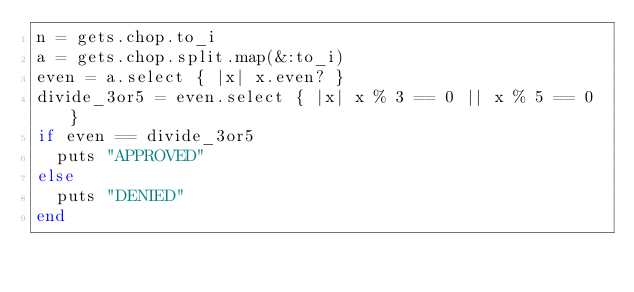<code> <loc_0><loc_0><loc_500><loc_500><_Ruby_>n = gets.chop.to_i
a = gets.chop.split.map(&:to_i)
even = a.select { |x| x.even? }
divide_3or5 = even.select { |x| x % 3 == 0 || x % 5 == 0 }
if even == divide_3or5
  puts "APPROVED"
else
  puts "DENIED"
end</code> 